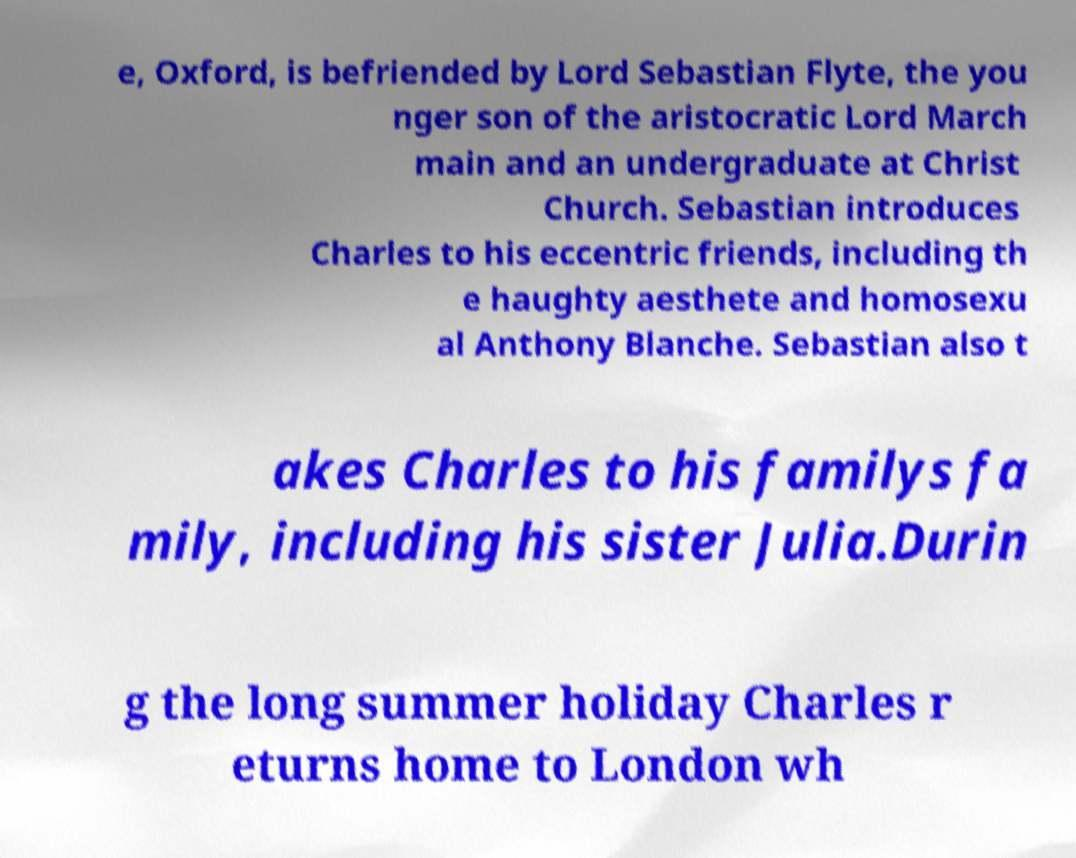Can you read and provide the text displayed in the image?This photo seems to have some interesting text. Can you extract and type it out for me? e, Oxford, is befriended by Lord Sebastian Flyte, the you nger son of the aristocratic Lord March main and an undergraduate at Christ Church. Sebastian introduces Charles to his eccentric friends, including th e haughty aesthete and homosexu al Anthony Blanche. Sebastian also t akes Charles to his familys fa mily, including his sister Julia.Durin g the long summer holiday Charles r eturns home to London wh 